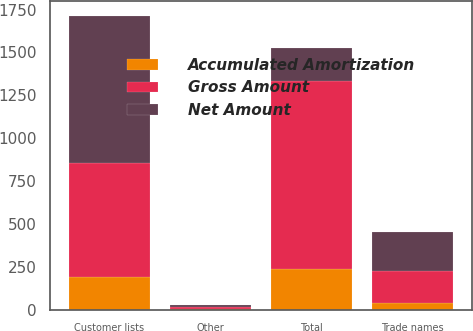<chart> <loc_0><loc_0><loc_500><loc_500><stacked_bar_chart><ecel><fcel>Customer lists<fcel>Trade names<fcel>Other<fcel>Total<nl><fcel>Net Amount<fcel>857.2<fcel>226.2<fcel>14.4<fcel>190.9<nl><fcel>Accumulated Amortization<fcel>190.9<fcel>36.8<fcel>3.8<fcel>238<nl><fcel>Gross Amount<fcel>666.3<fcel>189.4<fcel>10.6<fcel>1094.8<nl></chart> 